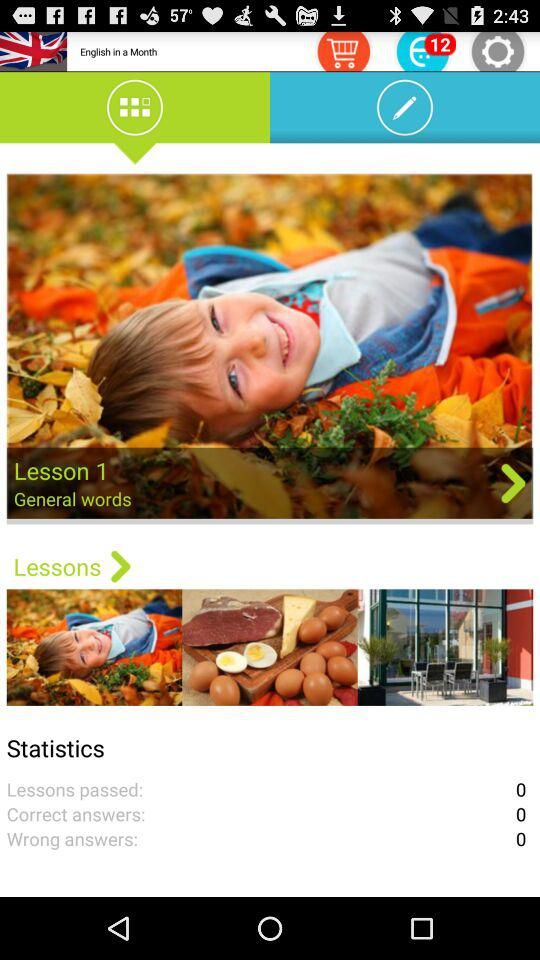What is the title of the lesson? The title of the lesson is "General words". 